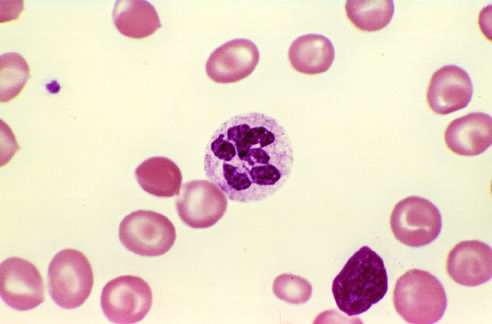how does a peripheral blood smear show a hyper-segmented neutrophil?
Answer the question using a single word or phrase. With a six-lobed nucleus 